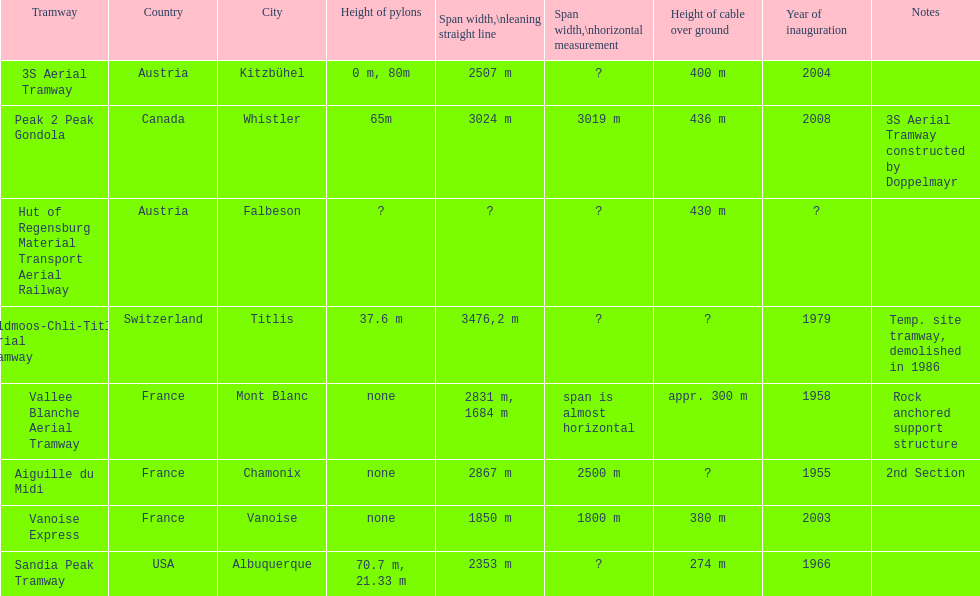Was the peak 2 peak gondola inaugurated before the vanoise express? No. 